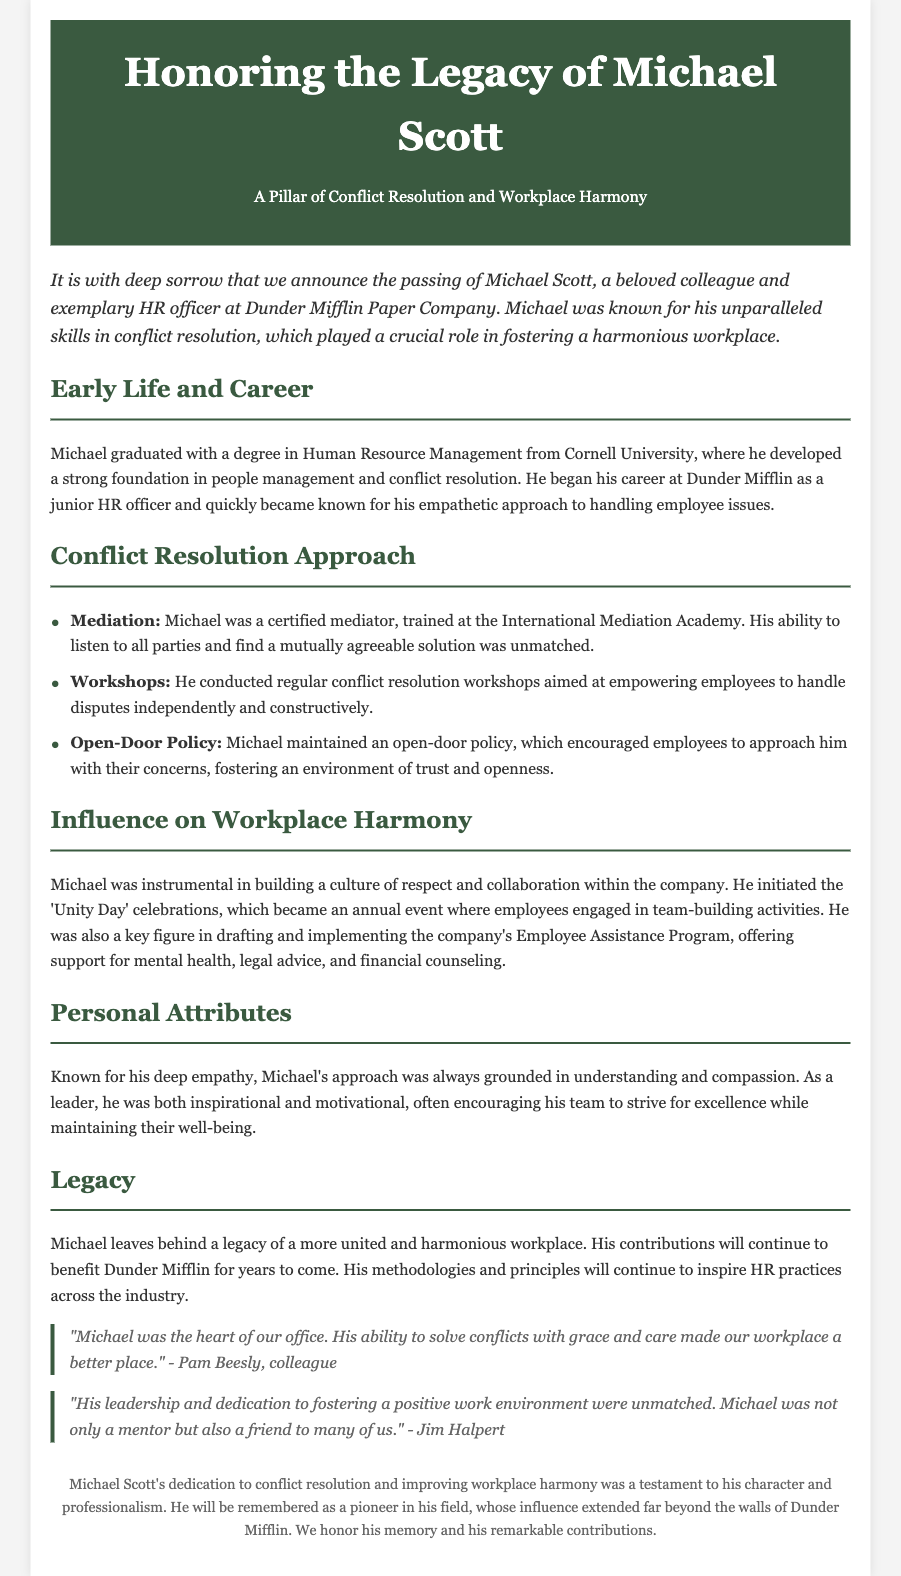What is the full name of the employee being honored? The document explicitly states the name of the employee being honored at the beginning.
Answer: Michael Scott What was Michael's degree? The document mentions Michael graduated with a degree in Human Resource Management.
Answer: Human Resource Management Which university did Michael graduate from? The document indicates the institution where Michael obtained his degree.
Answer: Cornell University What meditation certification did Michael hold? The document states that Michael was a certified mediator trained at a specific organization.
Answer: International Mediation Academy What was the name of the annual event Michael initiated? The document refers to an event that Michael started within the company.
Answer: Unity Day What approach did Michael maintain for employee concerns? The document describes how Michael encouraged open communication regarding employee issues.
Answer: Open-Door Policy Who described Michael as the heart of their office? The document includes quotes from colleagues reflecting on Michael's impact.
Answer: Pam Beesly What was one of the personal attributes of Michael? The document highlights distinct qualities that defined Michael as a person.
Answer: Empathy What did Michael contribute to for workplace support? The document mentions a specific program that Michael was pivotal in drafting and implementing.
Answer: Employee Assistance Program 